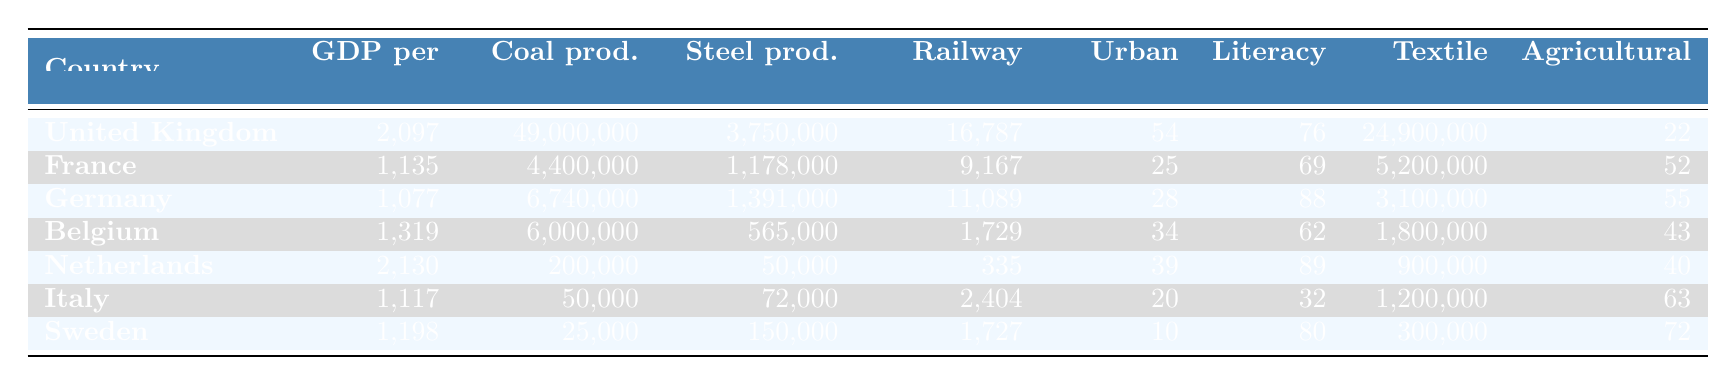What is the GDP per capita of the United Kingdom in 1800? The table indicates the GDP per capita for the United Kingdom (UK) in 1800 is listed as 2,097.
Answer: 2,097 Which country had the highest coal production in 1850? By examining the coal production figures for each country, the United Kingdom had the highest amount at 49,000,000 tons.
Answer: United Kingdom What percentage of the population was urban in Belgium in 1850? According to the table, Belgium had an urban population percentage of 34% in 1850.
Answer: 34% Calculate the average GDP per capita for the four countries with the highest GDP per capita in 1800. The four countries with the highest GDP per capita are the United Kingdom (2,097), Netherlands (2,130), France (1,135), and Germany (1,077). Summing these values gives 2,097 + 2,130 + 1,135 + 1,077 = 6,439. There are 4 countries, so the average GDP per capita is 6,439 / 4 = 1,609.75.
Answer: 1,609.75 True or False: Sweden had a higher literacy rate than France in 1870. The table shows Sweden's literacy rate in 1870 as 80% and France's as 69%. Since 80% is greater than 69%, the statement is true.
Answer: True What is the difference in steel production between the United Kingdom and Germany in 1870? The steel production for the United Kingdom is 3,750,000 tons and for Germany is 1,391,000 tons. The difference is calculated by subtracting Germany's number from the UK's: 3,750,000 - 1,391,000 = 2,359,000 tons.
Answer: 2,359,000 tons Which country had the lowest urban population percentage in 1850, and what was that percentage? By examining the urban population percentages in 1850, Sweden had the lowest at 10%.
Answer: Sweden, 10% If we consider the textile exports (£, 1840) for the countries, which country had the lowest value, and what was it? The table indicates that Italy had the lowest textile exports at 1,200,000 pounds in 1840.
Answer: Italy, 1,200,000 pounds Which country experienced the greatest percentage of its workforce in agriculture in 1850? The data shows Italy had the highest percentage of its workforce in agriculture at 63%.
Answer: Italy, 63% Calculate the total coal production of Germany and Belgium in 1850. Germany produced 6,740,000 tons and Belgium produced 6,000,000 tons of coal in 1850. Adding these figures together gives 6,740,000 + 6,000,000 = 12,740,000 tons of coal.
Answer: 12,740,000 tons Did the Netherlands have a higher railway length than France in 1860? The table shows the Netherlands had a railway length of 335 km while France had 9,167 km, so the statement is false.
Answer: False 